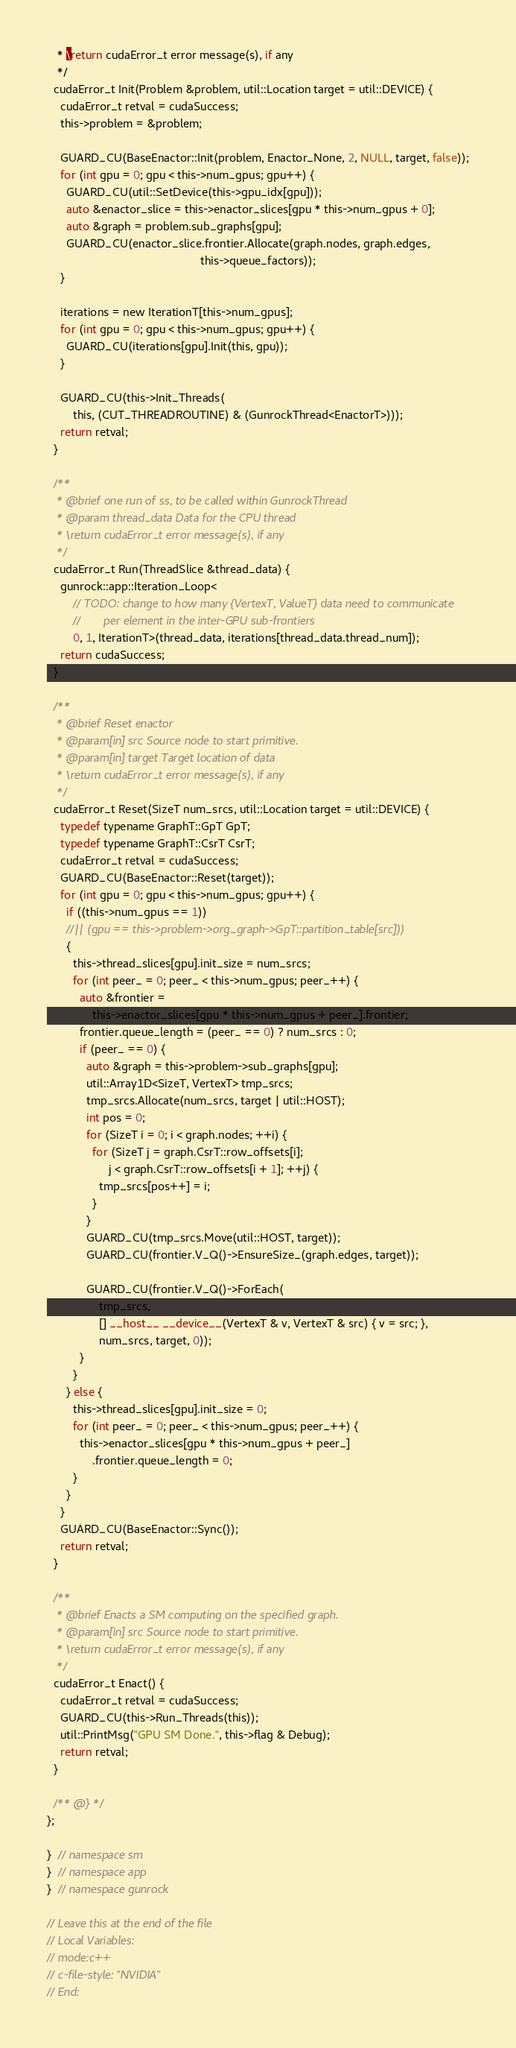Convert code to text. <code><loc_0><loc_0><loc_500><loc_500><_Cuda_>   * \return cudaError_t error message(s), if any
   */
  cudaError_t Init(Problem &problem, util::Location target = util::DEVICE) {
    cudaError_t retval = cudaSuccess;
    this->problem = &problem;

    GUARD_CU(BaseEnactor::Init(problem, Enactor_None, 2, NULL, target, false));
    for (int gpu = 0; gpu < this->num_gpus; gpu++) {
      GUARD_CU(util::SetDevice(this->gpu_idx[gpu]));
      auto &enactor_slice = this->enactor_slices[gpu * this->num_gpus + 0];
      auto &graph = problem.sub_graphs[gpu];
      GUARD_CU(enactor_slice.frontier.Allocate(graph.nodes, graph.edges,
                                               this->queue_factors));
    }

    iterations = new IterationT[this->num_gpus];
    for (int gpu = 0; gpu < this->num_gpus; gpu++) {
      GUARD_CU(iterations[gpu].Init(this, gpu));
    }

    GUARD_CU(this->Init_Threads(
        this, (CUT_THREADROUTINE) & (GunrockThread<EnactorT>)));
    return retval;
  }

  /**
   * @brief one run of ss, to be called within GunrockThread
   * @param thread_data Data for the CPU thread
   * \return cudaError_t error message(s), if any
   */
  cudaError_t Run(ThreadSlice &thread_data) {
    gunrock::app::Iteration_Loop<
        // TODO: change to how many {VertexT, ValueT} data need to communicate
        //       per element in the inter-GPU sub-frontiers
        0, 1, IterationT>(thread_data, iterations[thread_data.thread_num]);
    return cudaSuccess;
  }

  /**
   * @brief Reset enactor
   * @param[in] src Source node to start primitive.
   * @param[in] target Target location of data
   * \return cudaError_t error message(s), if any
   */
  cudaError_t Reset(SizeT num_srcs, util::Location target = util::DEVICE) {
    typedef typename GraphT::GpT GpT;
    typedef typename GraphT::CsrT CsrT;
    cudaError_t retval = cudaSuccess;
    GUARD_CU(BaseEnactor::Reset(target));
    for (int gpu = 0; gpu < this->num_gpus; gpu++) {
      if ((this->num_gpus == 1))
      //|| (gpu == this->problem->org_graph->GpT::partition_table[src]))
      {
        this->thread_slices[gpu].init_size = num_srcs;
        for (int peer_ = 0; peer_ < this->num_gpus; peer_++) {
          auto &frontier =
              this->enactor_slices[gpu * this->num_gpus + peer_].frontier;
          frontier.queue_length = (peer_ == 0) ? num_srcs : 0;
          if (peer_ == 0) {
            auto &graph = this->problem->sub_graphs[gpu];
            util::Array1D<SizeT, VertexT> tmp_srcs;
            tmp_srcs.Allocate(num_srcs, target | util::HOST);
            int pos = 0;
            for (SizeT i = 0; i < graph.nodes; ++i) {
              for (SizeT j = graph.CsrT::row_offsets[i];
                   j < graph.CsrT::row_offsets[i + 1]; ++j) {
                tmp_srcs[pos++] = i;
              }
            }
            GUARD_CU(tmp_srcs.Move(util::HOST, target));
            GUARD_CU(frontier.V_Q()->EnsureSize_(graph.edges, target));

            GUARD_CU(frontier.V_Q()->ForEach(
                tmp_srcs,
                [] __host__ __device__(VertexT & v, VertexT & src) { v = src; },
                num_srcs, target, 0));
          }
        }
      } else {
        this->thread_slices[gpu].init_size = 0;
        for (int peer_ = 0; peer_ < this->num_gpus; peer_++) {
          this->enactor_slices[gpu * this->num_gpus + peer_]
              .frontier.queue_length = 0;
        }
      }
    }
    GUARD_CU(BaseEnactor::Sync());
    return retval;
  }

  /**
   * @brief Enacts a SM computing on the specified graph.
   * @param[in] src Source node to start primitive.
   * \return cudaError_t error message(s), if any
   */
  cudaError_t Enact() {
    cudaError_t retval = cudaSuccess;
    GUARD_CU(this->Run_Threads(this));
    util::PrintMsg("GPU SM Done.", this->flag & Debug);
    return retval;
  }

  /** @} */
};

}  // namespace sm
}  // namespace app
}  // namespace gunrock

// Leave this at the end of the file
// Local Variables:
// mode:c++
// c-file-style: "NVIDIA"
// End:
</code> 